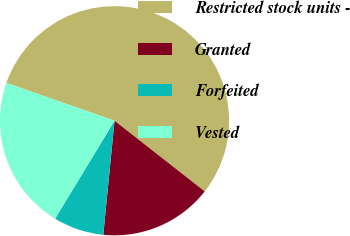Convert chart. <chart><loc_0><loc_0><loc_500><loc_500><pie_chart><fcel>Restricted stock units -<fcel>Granted<fcel>Forfeited<fcel>Vested<nl><fcel>55.22%<fcel>15.99%<fcel>7.12%<fcel>21.67%<nl></chart> 